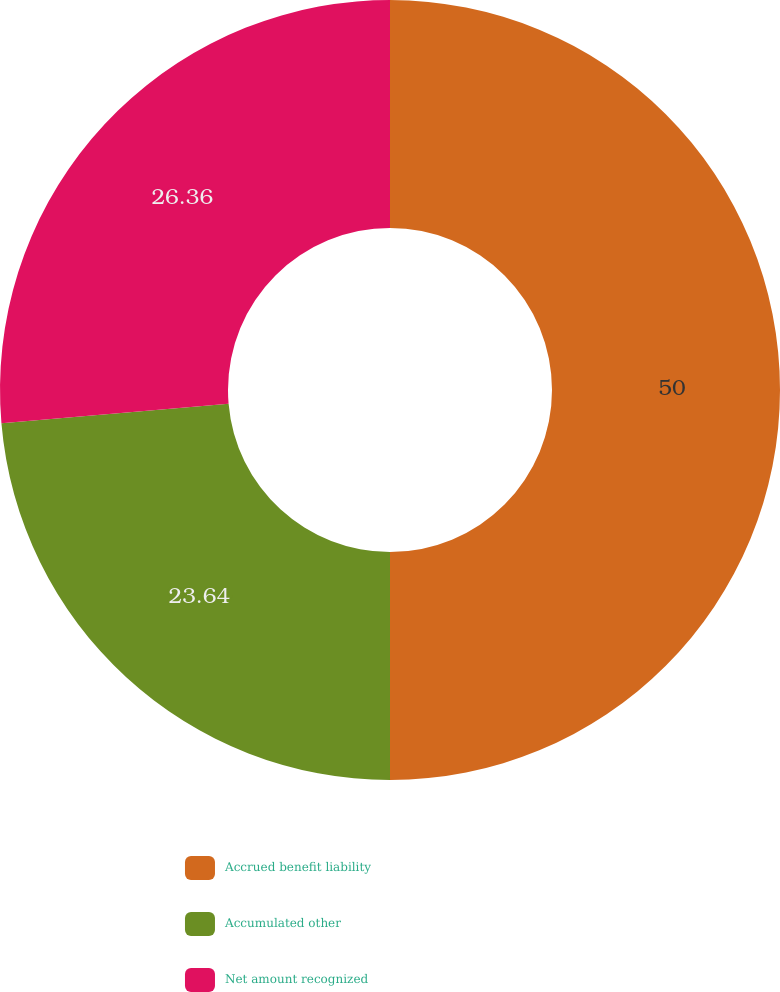Convert chart to OTSL. <chart><loc_0><loc_0><loc_500><loc_500><pie_chart><fcel>Accrued benefit liability<fcel>Accumulated other<fcel>Net amount recognized<nl><fcel>50.0%<fcel>23.64%<fcel>26.36%<nl></chart> 